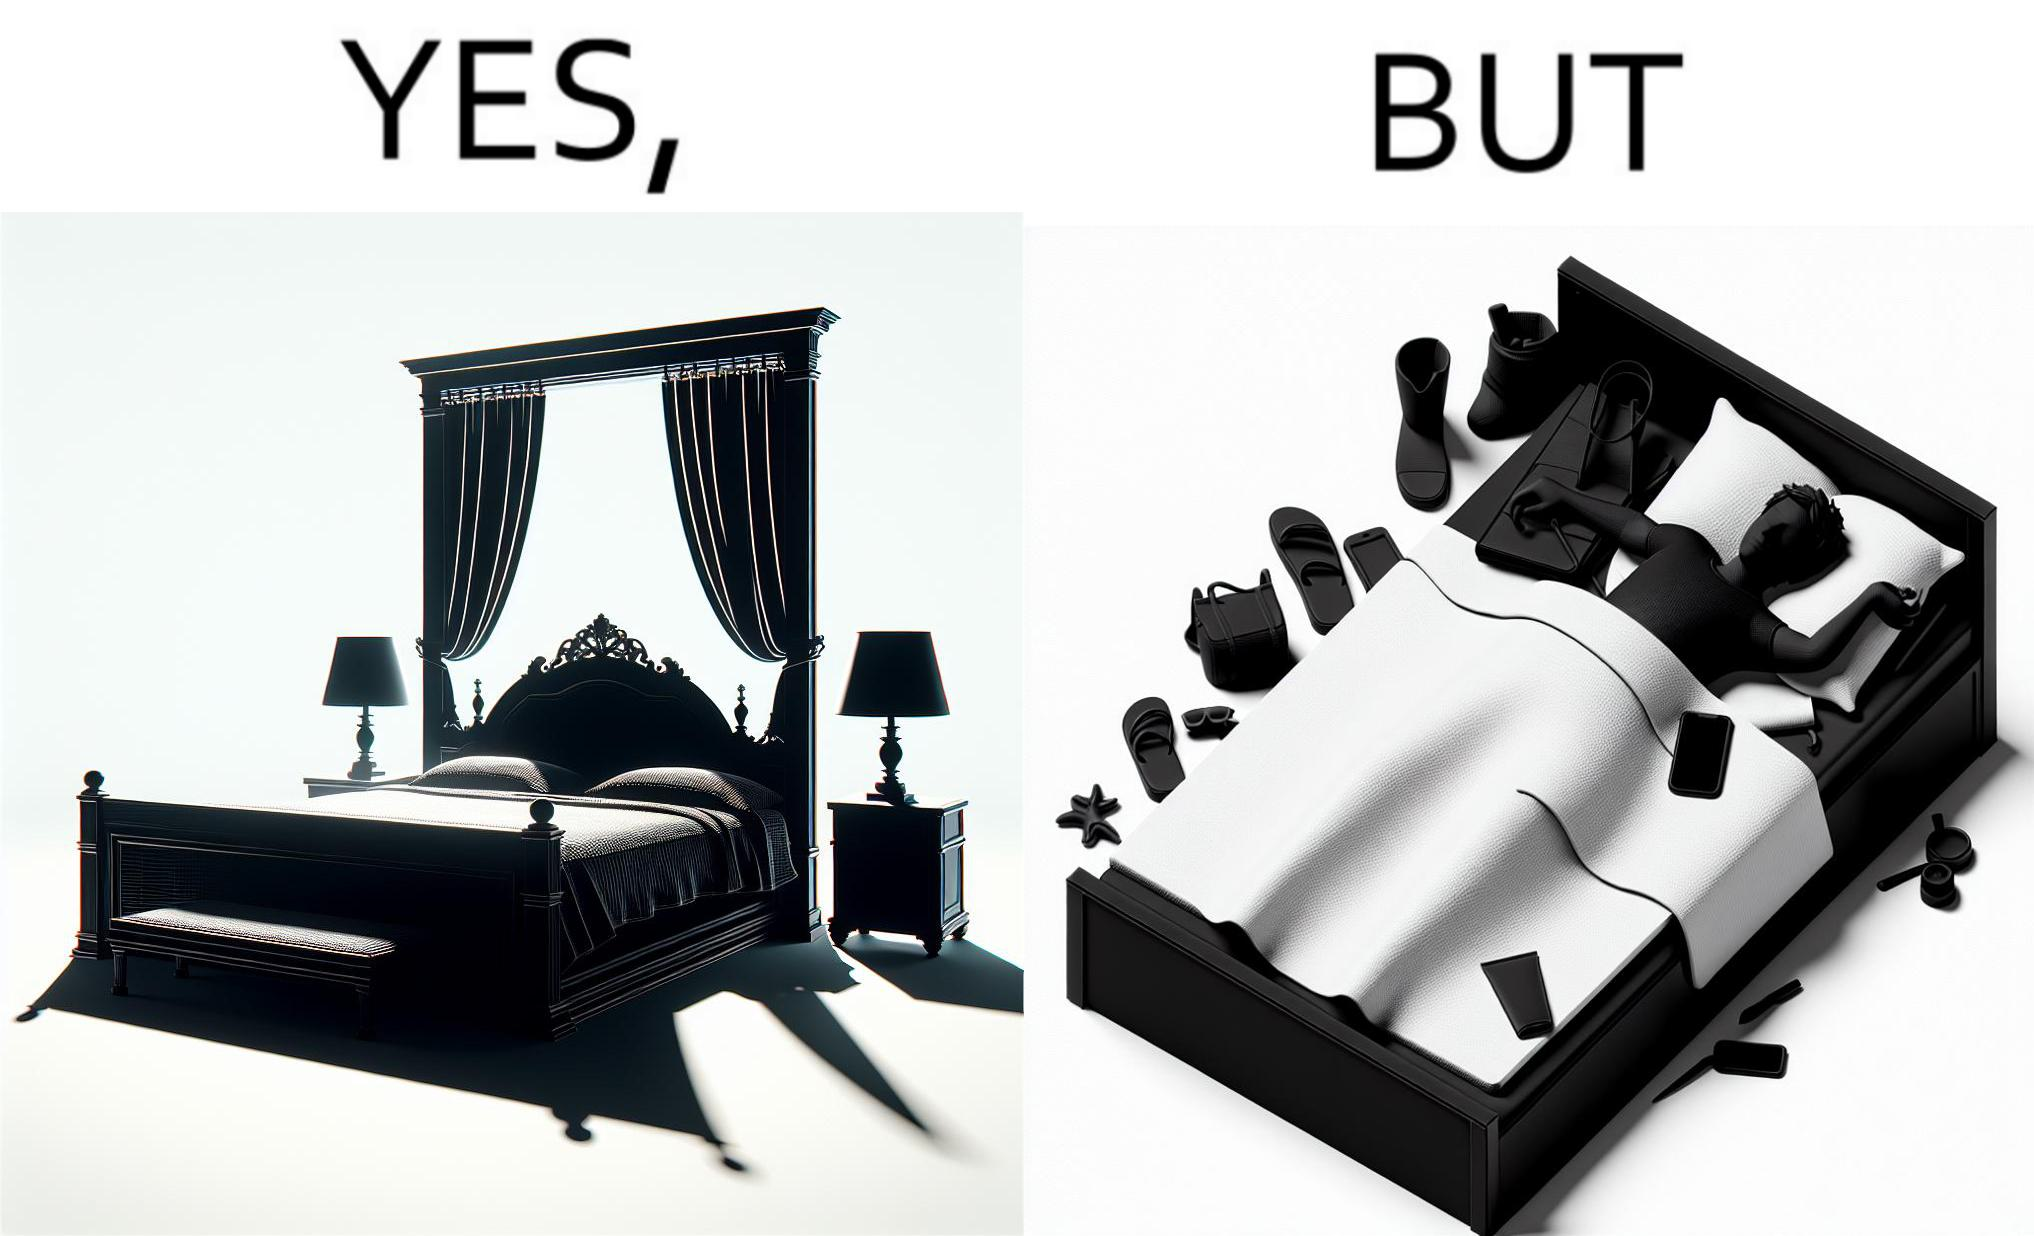What do you see in each half of this image? In the left part of the image: There is a bed of king size. In the right part of the image: There is a person sleeping with his material on its bed; 